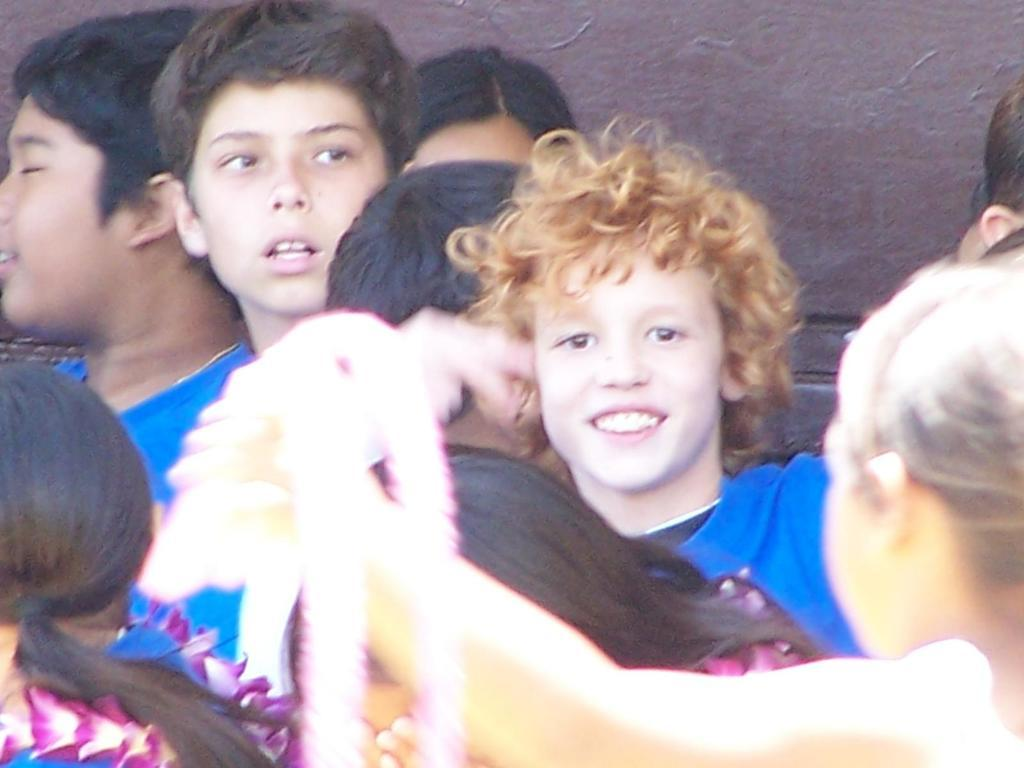What is the main subject in the foreground of the image? There is a group of people in the foreground of the image. What can be seen in the background of the image? There is a wall in the background of the image. What is the price of the house in the image? There is no house present in the image, so it is not possible to determine its price. 